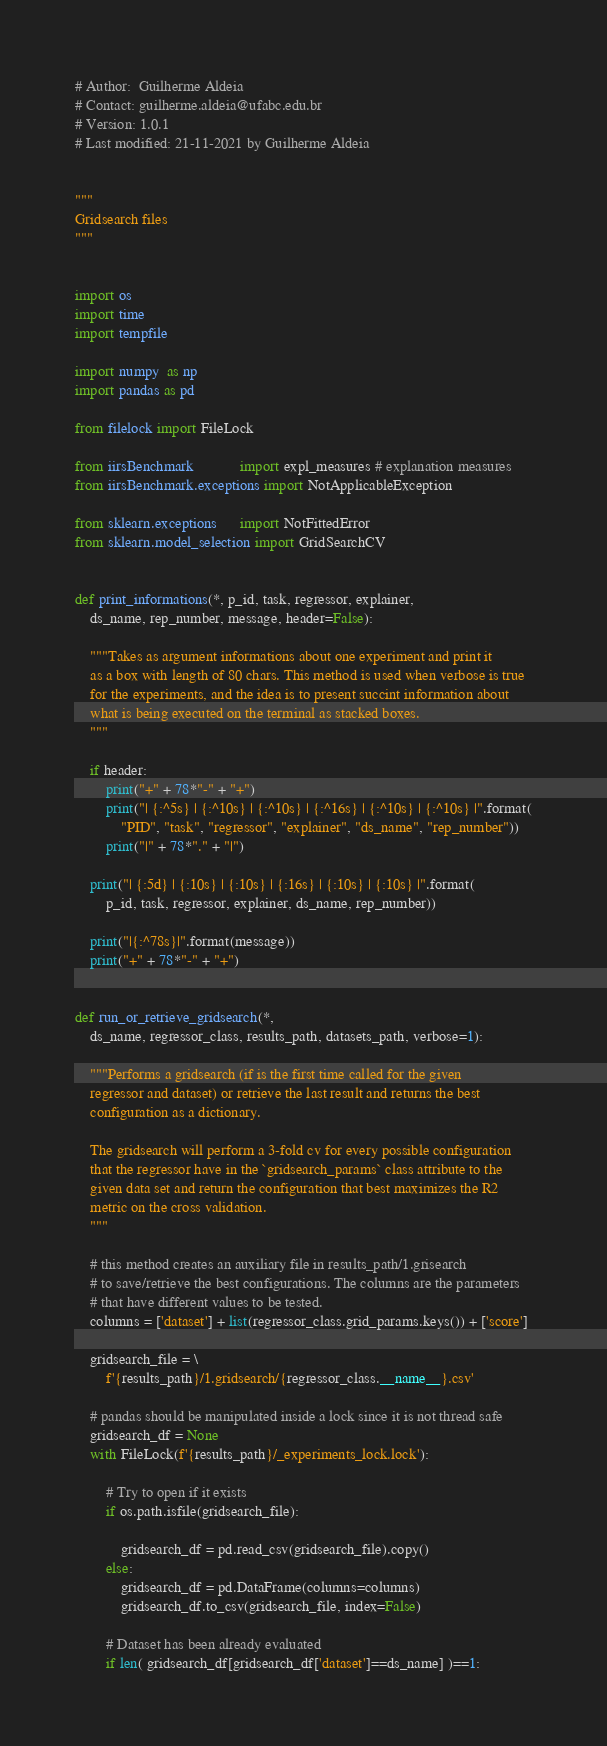Convert code to text. <code><loc_0><loc_0><loc_500><loc_500><_Python_>
# Author:  Guilherme Aldeia
# Contact: guilherme.aldeia@ufabc.edu.br
# Version: 1.0.1
# Last modified: 21-11-2021 by Guilherme Aldeia


"""
Gridsearch files
"""


import os
import time
import tempfile

import numpy  as np
import pandas as pd

from filelock import FileLock

from iirsBenchmark            import expl_measures # explanation measures
from iirsBenchmark.exceptions import NotApplicableException

from sklearn.exceptions      import NotFittedError
from sklearn.model_selection import GridSearchCV


def print_informations(*, p_id, task, regressor, explainer,
    ds_name, rep_number, message, header=False):

    """Takes as argument informations about one experiment and print it
    as a box with length of 80 chars. This method is used when verbose is true
    for the experiments, and the idea is to present succint information about
    what is being executed on the terminal as stacked boxes.
    """

    if header:
        print("+" + 78*"-" + "+")    
        print("| {:^5s} | {:^10s} | {:^10s} | {:^16s} | {:^10s} | {:^10s} |".format(
            "PID", "task", "regressor", "explainer", "ds_name", "rep_number"))
        print("|" + 78*"." + "|")  

    print("| {:5d} | {:10s} | {:10s} | {:16s} | {:10s} | {:10s} |".format(
        p_id, task, regressor, explainer, ds_name, rep_number))
    
    print("|{:^78s}|".format(message))
    print("+" + 78*"-" + "+")


def run_or_retrieve_gridsearch(*,
    ds_name, regressor_class, results_path, datasets_path, verbose=1):
    
    """Performs a gridsearch (if is the first time called for the given
    regressor and dataset) or retrieve the last result and returns the best
    configuration as a dictionary.
    
    The gridsearch will perform a 3-fold cv for every possible configuration
    that the regressor have in the `gridsearch_params` class attribute to the
    given data set and return the configuration that best maximizes the R2
    metric on the cross validation.
    """

    # this method creates an auxiliary file in results_path/1.grisearch
    # to save/retrieve the best configurations. The columns are the parameters
    # that have different values to be tested.
    columns = ['dataset'] + list(regressor_class.grid_params.keys()) + ['score']

    gridsearch_file = \
        f'{results_path}/1.gridsearch/{regressor_class.__name__}.csv'

    # pandas should be manipulated inside a lock since it is not thread safe
    gridsearch_df = None
    with FileLock(f'{results_path}/_experiments_lock.lock'):

        # Try to open if it exists
        if os.path.isfile(gridsearch_file):

            gridsearch_df = pd.read_csv(gridsearch_file).copy()
        else:
            gridsearch_df = pd.DataFrame(columns=columns)
            gridsearch_df.to_csv(gridsearch_file, index=False)

        # Dataset has been already evaluated
        if len( gridsearch_df[gridsearch_df['dataset']==ds_name] )==1:</code> 